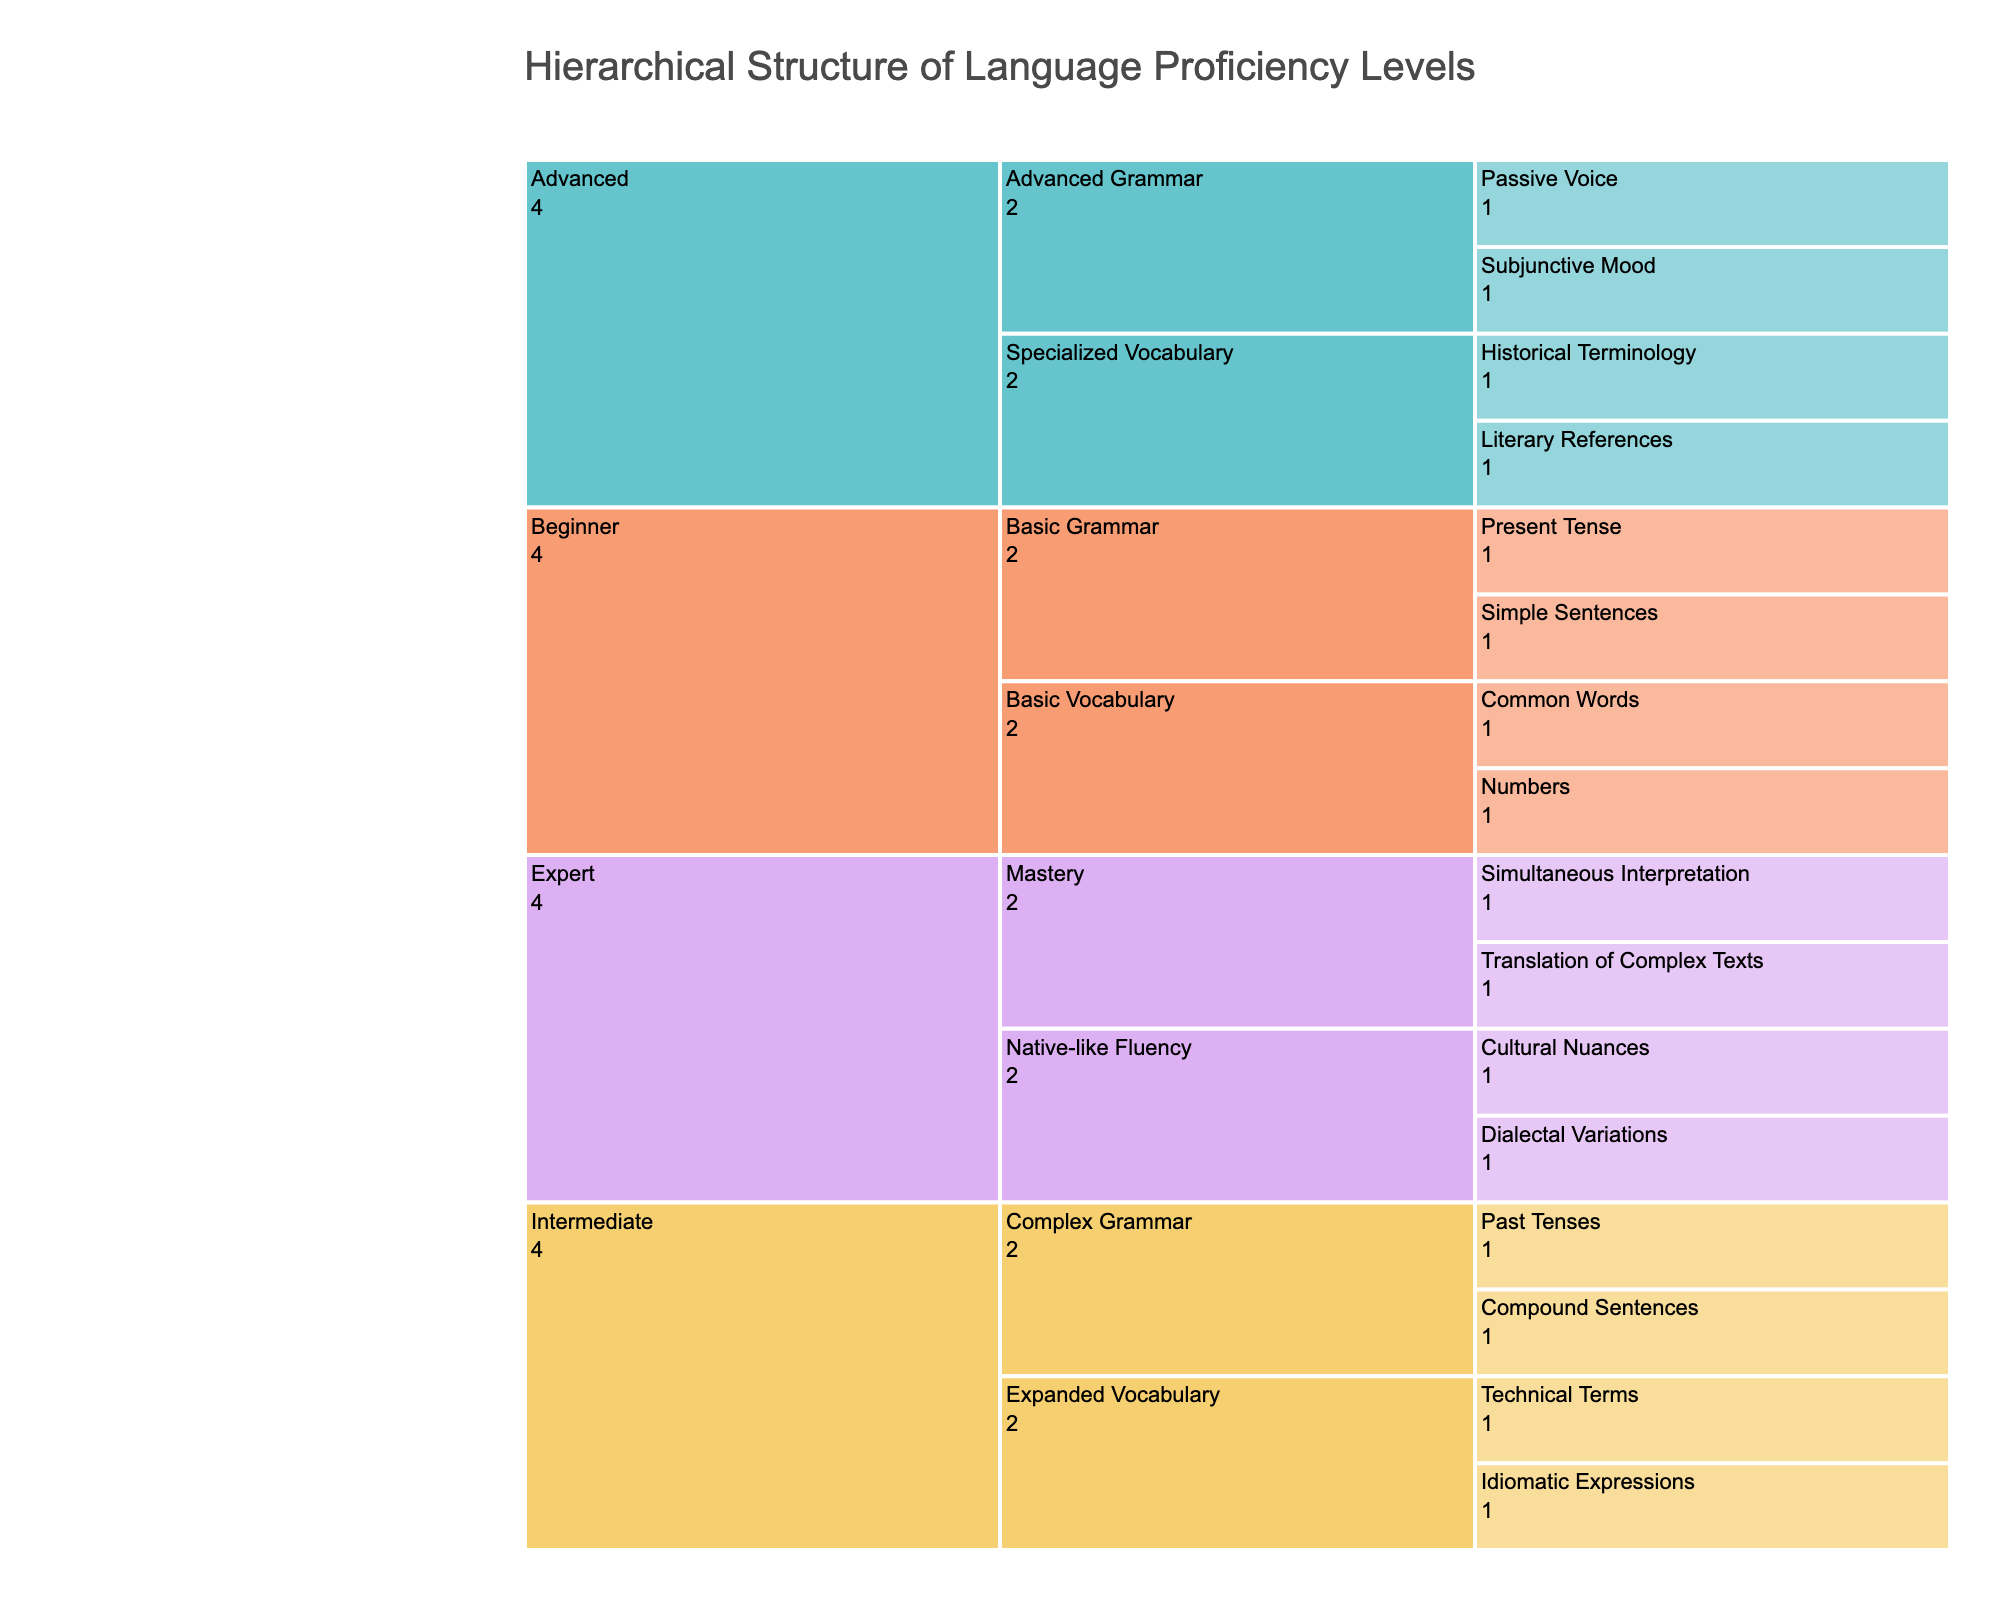What is the title of the chart? The title is located at the top center of the chart, providing an overview of the chart's content. It reads "Hierarchical Structure of Language Proficiency Levels".
Answer: Hierarchical Structure of Language Proficiency Levels How many proficiency levels are represented in the chart? By observing the first layer or the top division of the Icicle Chart, you can identify the distinct levels indicated by different colors. There are four proficiency levels: Beginner, Intermediate, Advanced, and Expert.
Answer: Four What are the subgroups under the Intermediate level? The Intermediate level divides into two subgroups: Expanded Vocabulary and Complex Grammar, which can be seen directly in the chart’s second layer under Intermediate.
Answer: Expanded Vocabulary and Complex Grammar How many skills are listed under the Advanced proficiency level? The Advanced level further divides into two subgroups, each containing specific skills. Counting the skills listed for both Specialized Vocabulary and Advanced Grammar gives us a total.
Answer: Four skills Which level contains the skill “Cultural Nuances”? By following the path from Beginner to Expert and mapping out each level’s subgroups, the skill “Cultural Nuances” is found under the Expert level, within the Native-like Fluency subgroup.
Answer: Expert How does the number of skills in the Beginner level compare to those in the Advanced level? To compare, count the skills in both levels. In Beginner, there are four skills (Common Words, Numbers, Simple Sentences, Present Tense). In Advanced, there are also four skills (Literary References, Historical Terminology, Subjunctive Mood, Passive Voice).
Answer: They are equal Which level and subgroup contain the skill “Simultaneous Interpretation”? Trace the hierarchy from the top level to locate the specific subgroup that contains "Simultaneous Interpretation." It is within the Expert level under the Mastery subgroup.
Answer: Expert, Mastery Compare the number of skills under "Basic Vocabulary" and "Advanced Grammar". Which subgroup has more skills? Count the skills listed under each subgroup. Basic Vocabulary has two skills (Common Words, Numbers) while Advanced Grammar has two as well (Subjunctive Mood, Passive Voice).
Answer: They are equal What skill belongs to both Intermediate and Advanced levels but in different subgroups? Carefully scan through the skills listed under these levels; "Technical Terms" and "Historical Terminology" appear similar, but each belongs to different subgroups. None is actually repeated across these levels.
Answer: None 